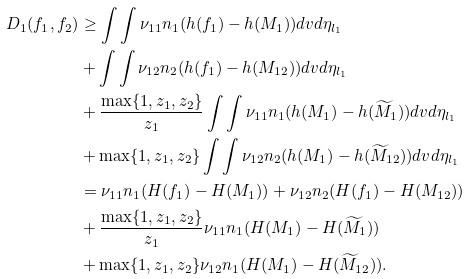Convert formula to latex. <formula><loc_0><loc_0><loc_500><loc_500>D _ { 1 } ( f _ { 1 } , f _ { 2 } ) & \geq \int \int \nu _ { 1 1 } n _ { 1 } ( h ( f _ { 1 } ) - h ( M _ { 1 } ) ) d v d \eta _ { l _ { 1 } } \\ & + \int \int \nu _ { 1 2 } n _ { 2 } ( h ( f _ { 1 } ) - h ( M _ { 1 2 } ) ) d v d \eta _ { l _ { 1 } } \\ & + \frac { \max \{ 1 , z _ { 1 } , z _ { 2 } \} } { z _ { 1 } } \int \int \nu _ { 1 1 } n _ { 1 } ( h ( M _ { 1 } ) - h ( \widetilde { M } _ { 1 } ) ) d v d \eta _ { l _ { 1 } } \\ & + \max \{ 1 , z _ { 1 } , z _ { 2 } \} \int \int \nu _ { 1 2 } n _ { 2 } ( h ( M _ { 1 } ) - h ( \widetilde { M } _ { 1 2 } ) ) d v d \eta _ { l _ { 1 } } \\ & = \nu _ { 1 1 } n _ { 1 } ( H ( f _ { 1 } ) - H ( M _ { 1 } ) ) + \nu _ { 1 2 } n _ { 2 } ( H ( f _ { 1 } ) - H ( M _ { 1 2 } ) ) \\ & + \frac { \max \{ 1 , z _ { 1 } , z _ { 2 } \} } { z _ { 1 } } \nu _ { 1 1 } n _ { 1 } ( H ( M _ { 1 } ) - H ( \widetilde { M } _ { 1 } ) ) \\ & + \max \{ 1 , z _ { 1 } , z _ { 2 } \} \nu _ { 1 2 } n _ { 1 } ( H ( M _ { 1 } ) - H ( \widetilde { M } _ { 1 2 } ) ) .</formula> 